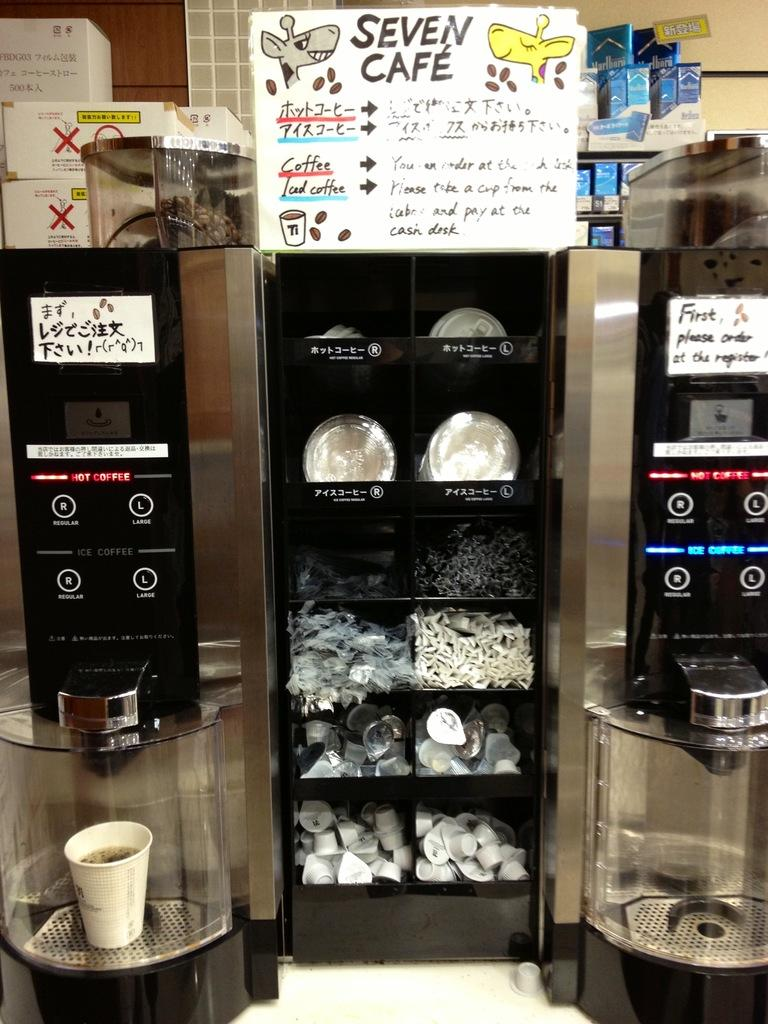<image>
Describe the image concisely. two coffee machines on a table under a sign Seven Cafe 